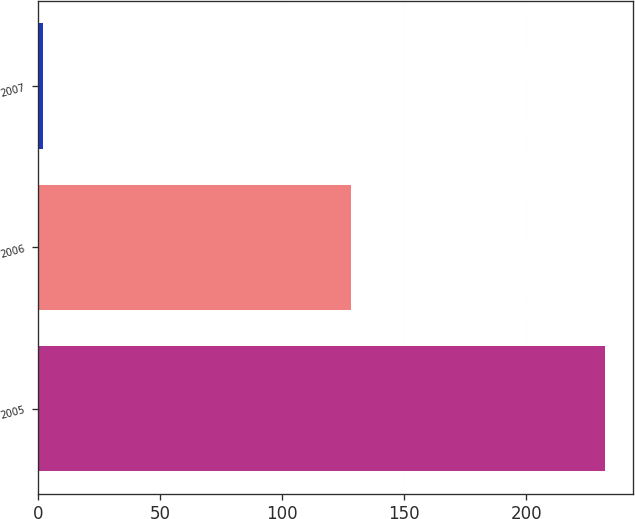Convert chart to OTSL. <chart><loc_0><loc_0><loc_500><loc_500><bar_chart><fcel>2005<fcel>2006<fcel>2007<nl><fcel>232<fcel>128<fcel>2<nl></chart> 